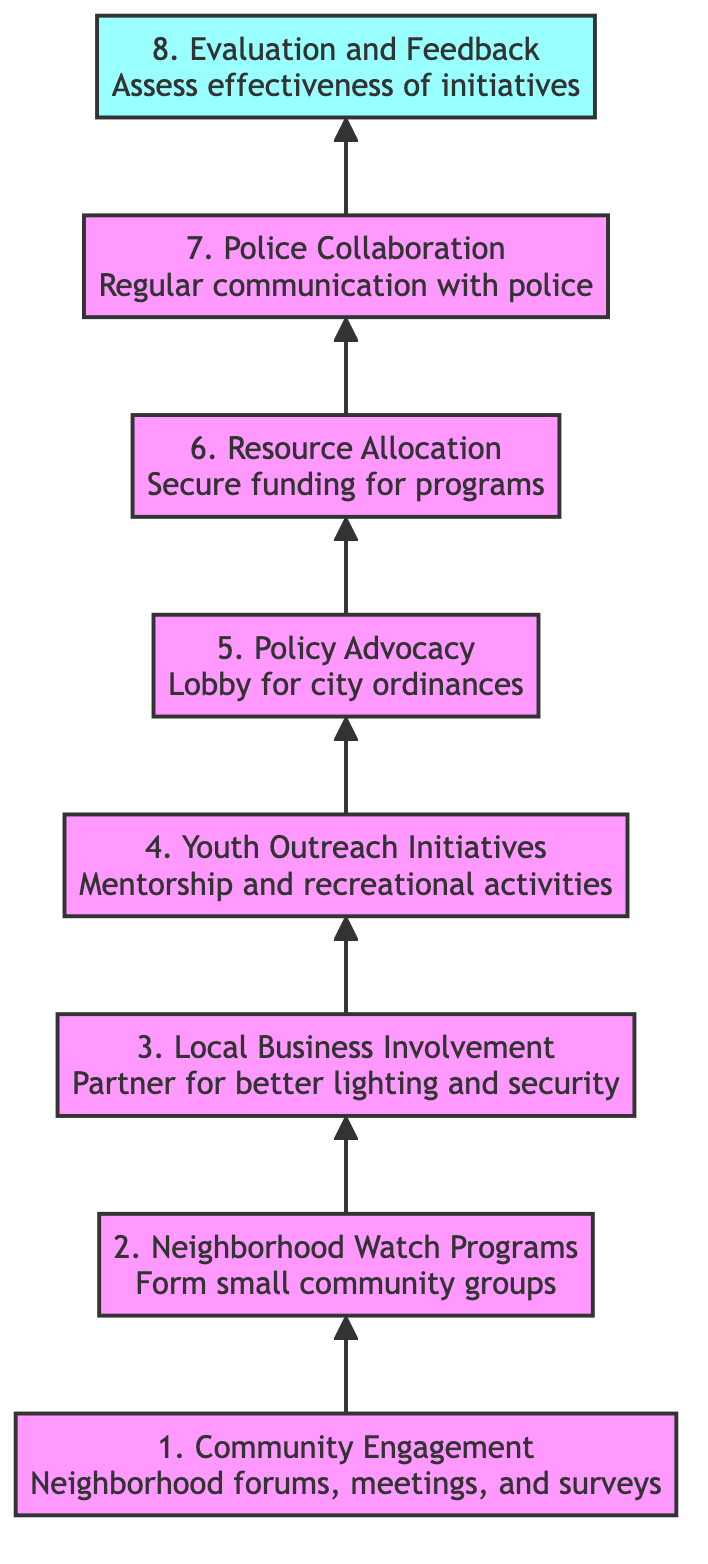What is the topmost element in the diagram? The diagram flows from bottom to top, and the topmost element is labeled as "Evaluation and Feedback".
Answer: Evaluation and Feedback How many levels are represented in the diagram? The diagram has a total of 8 distinct levels, starting from "Community Engagement" at the bottom to "Evaluation and Feedback" at the top.
Answer: 8 Which element directly follows "Resource Allocation"? In the flow of the diagram, "Police Collaboration" is the next element that follows "Resource Allocation".
Answer: Police Collaboration What is one of the purposes of "Youth Outreach Initiatives"? According to the diagram, "Youth Outreach Initiatives" aims to engage at-risk youth through mentorship programs and recreational activities.
Answer: Mentorship programs Which two elements are connected by an arrow? The diagram indicates that "Local Business Involvement" is connected to "Youth Outreach Initiatives" with a directional arrow indicating the flow of the strategy.
Answer: Local Business Involvement and Youth Outreach Initiatives What types of actions are indicated under "Community Engagement"? The diagram specifies actions such as neighborhood forums, meetings, and surveys to understand resident concerns as part of "Community Engagement".
Answer: Neighborhood forums, meetings, and surveys How does "Policy Advocacy" contribute to the overall strategy? "Policy Advocacy" is a critical element that involves lobbying for city ordinances to address issues like loitering and property crime, contributing to the overarching goal of crime reduction.
Answer: Lobbying for city ordinances What is the final step in the crime reduction strategy? The last step depicted in the diagram is "Evaluation and Feedback," performed to regularly assess the effectiveness of initiatives and make adjustments as needed.
Answer: Evaluation and Feedback 